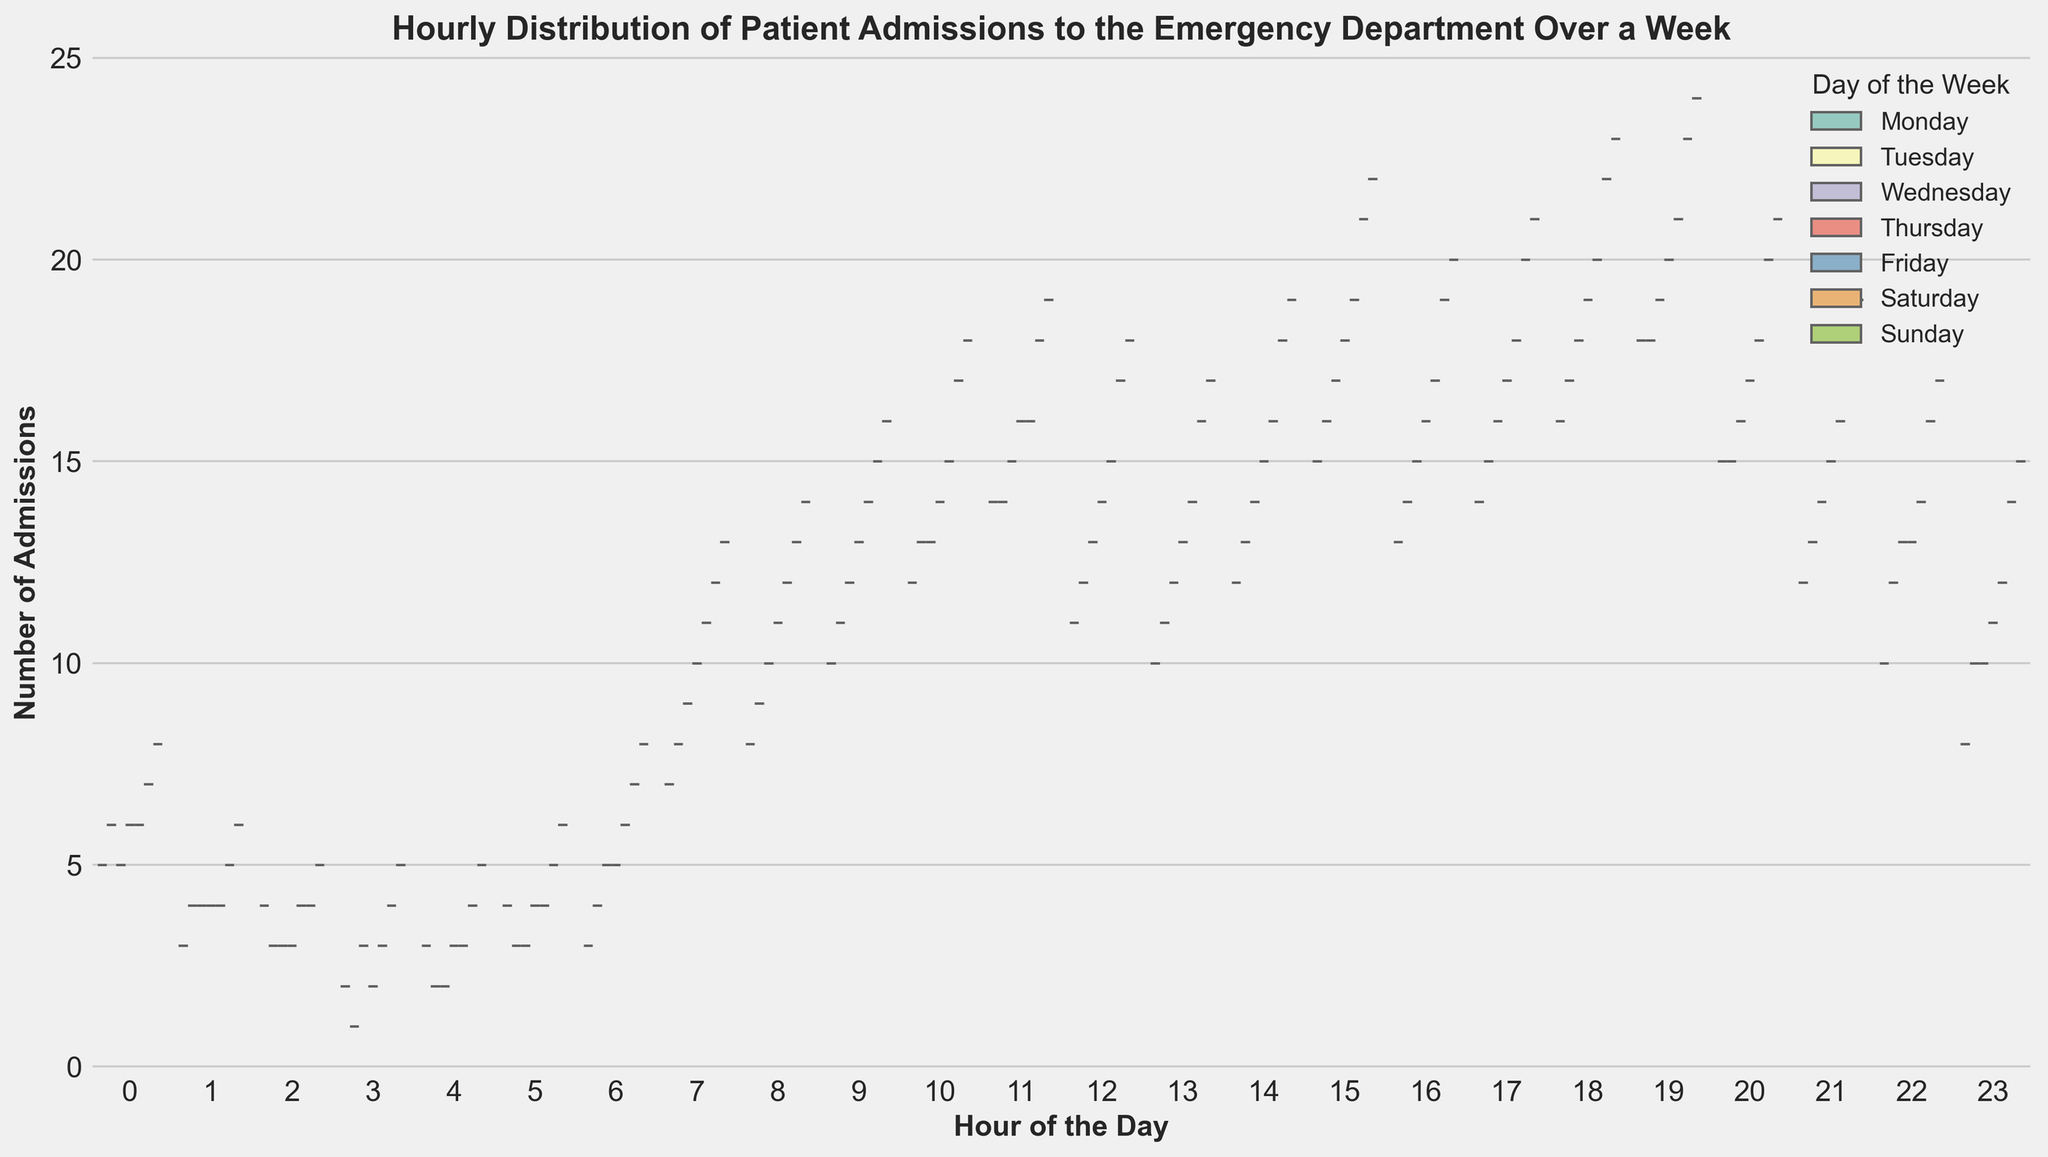What's the general trend in patient admissions throughout the week? The violin plot illustrates each day's distribution of admissions throughout the hours. Generally, the spread and density of admissions increase as the week progresses, peaking on the weekends, particularly Saturday and Sunday.
Answer: Increasing trend peaking on weekends During which hours do patient admissions tend to peak across all days? By observing the height and density of the violins, patient admissions tend to peak around late afternoon to evening hours, particularly from 15:00 to 19:00.
Answer: 15:00 to 19:00 Which day shows the highest number of admissions in the early morning hours (00:00 - 06:00)? Comparing the violin plots for the early morning across all days, Sunday shows the highest density and range of admissions in the early morning hours.
Answer: Sunday How do patient admissions on Wednesday at noon compare to those at 3 AM? The height and density of the plot for Wednesday indicate higher admissions around noon compared to the flatter, less dense distribution at 3 AM.
Answer: Higher at noon Which day of the week has the most typically varied range of patient admissions? By examining the width of the violins, Saturday displays the widest range of admissions across multiple hours, indicating a greater variability.
Answer: Saturday Are there any days with consistently low admissions in the early morning? Reviewing the early morning (00:00 - 06:00) for each day, Monday, Wednesday, and Thursday show consistently low admissions during these hours.
Answer: Monday, Wednesday, Thursday What's the comparison between weekday (Monday to Friday) and weekend (Saturday and Sunday) patient admission patterns? The violin plots indicate denser and more frequent admissions on weekends, especially from late afternoon to night, while weekdays have a more gradual increase throughout the day with fewer admissions early and late.
Answer: Weekends have higher and denser admissions Which hours show the least variance in admissions across all days? The least variance appears in the early morning hours (02:00 - 06:00 and midnight hours), as indicated by the narrower and consistent violin plots.
Answer: 02:00 - 06:00 How does the admission pattern on Thursday afternoon differ from that on Thursday morning? The violin for Thursday afternoon (from 12:00 to 18:00) is much denser and taller than that in the morning (00:00 to 12:00), indicating higher admissions during the afternoon hours.
Answer: Higher admissions in the afternoon On which day and during which hour is the peak admission noted? By analyzing the violin plots, Saturday at 19:00 seems to have the peak admission, showing the highest density and maximum height.
Answer: Saturday at 19:00 